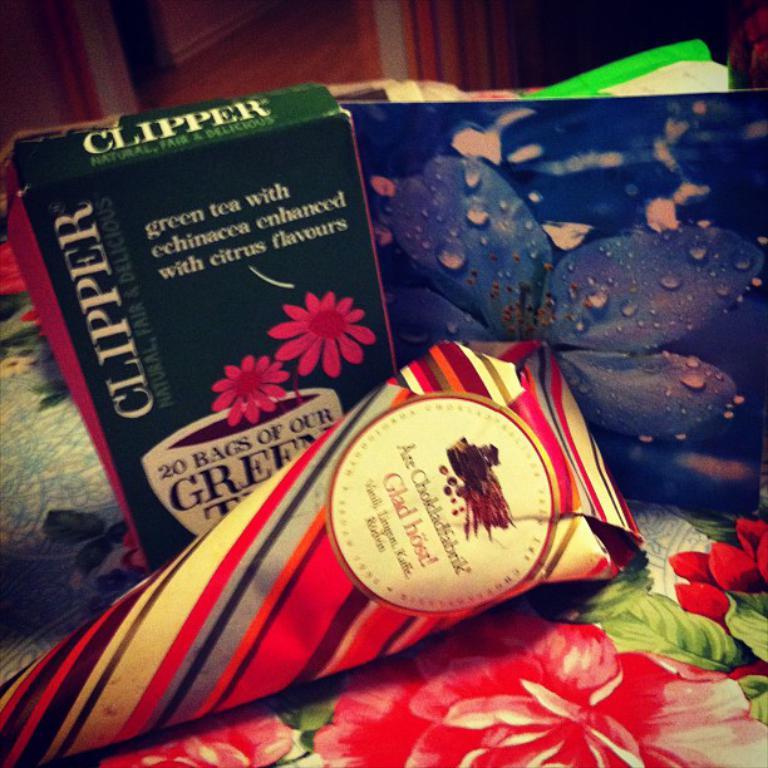How many bags of tea are in the box?
Make the answer very short. 20. 